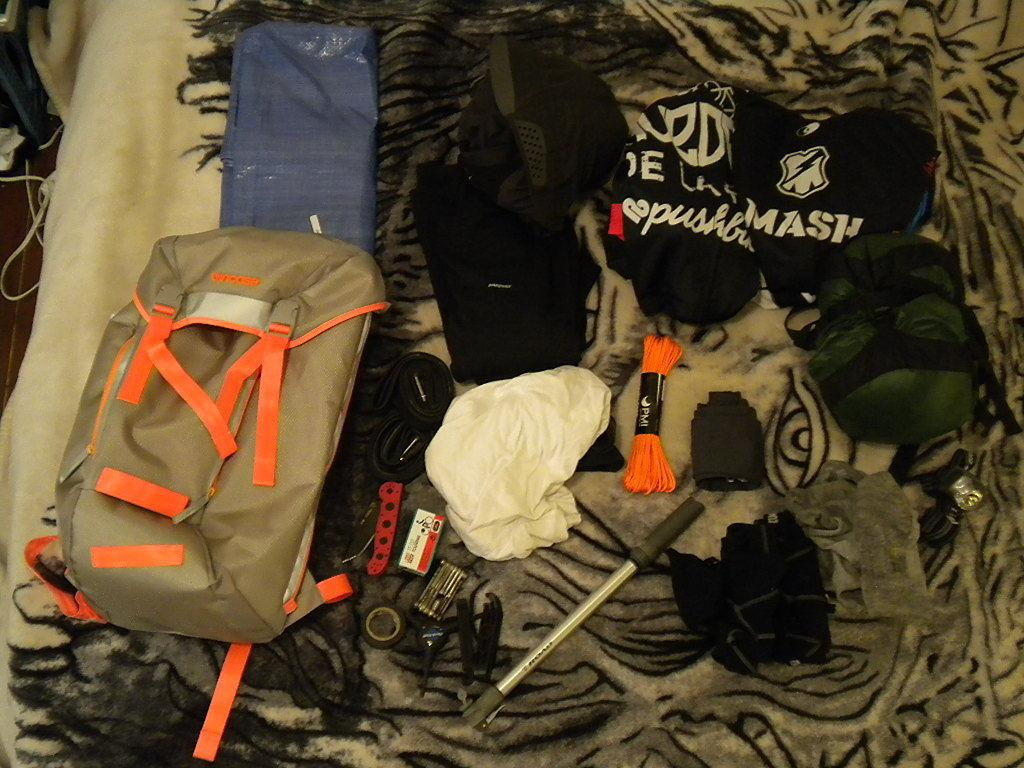What is the main object in the image? There is a cloth in the image. What is placed on the cloth? There are bags, threads, a pen, and other items on the cloth. Can you describe the pen on the cloth? The pen is an item placed on the cloth. What type of material might the bags be made of? The bags on the cloth might be made of fabric, paper, or other materials. What type of watch can be seen on the cloth? There is no watch present on the cloth in the image. What scientific experiment is being conducted on the cloth? There is no scientific experiment or any reference to science in the image. 